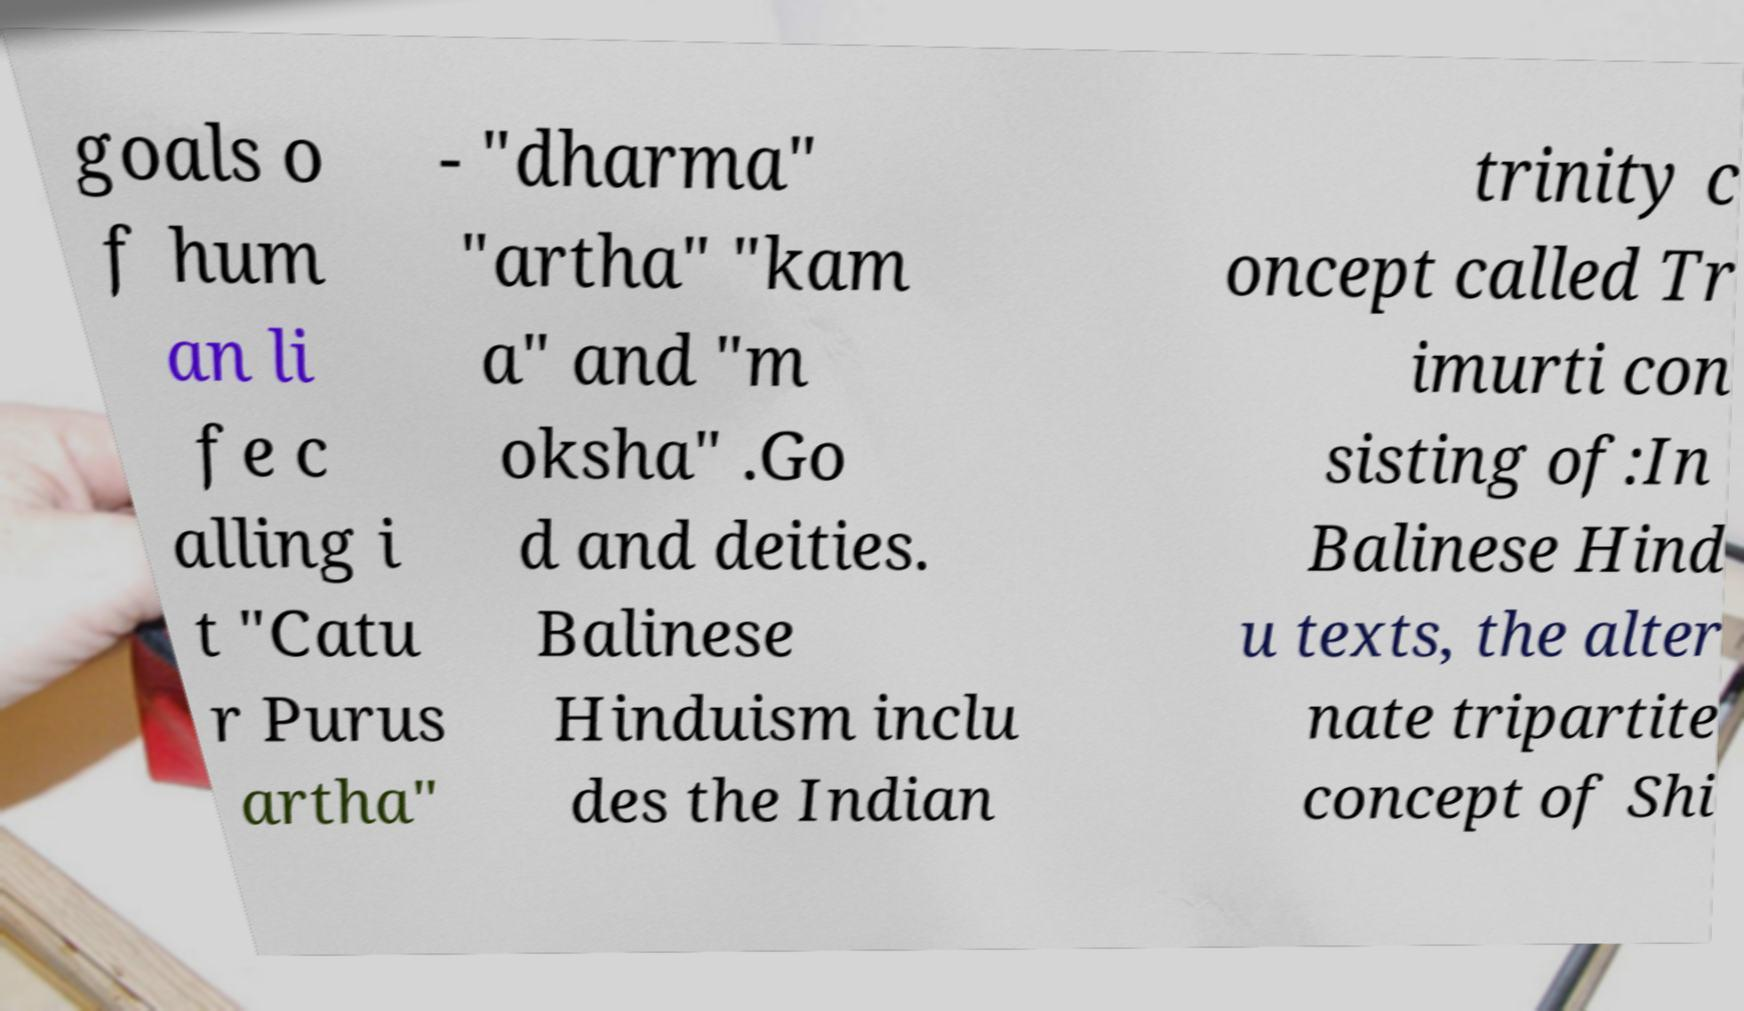Could you assist in decoding the text presented in this image and type it out clearly? goals o f hum an li fe c alling i t "Catu r Purus artha" - "dharma" "artha" "kam a" and "m oksha" .Go d and deities. Balinese Hinduism inclu des the Indian trinity c oncept called Tr imurti con sisting of:In Balinese Hind u texts, the alter nate tripartite concept of Shi 